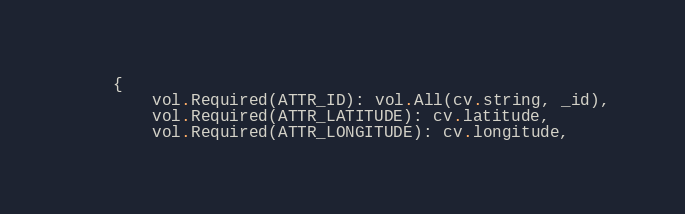<code> <loc_0><loc_0><loc_500><loc_500><_Python_>    {
        vol.Required(ATTR_ID): vol.All(cv.string, _id),
        vol.Required(ATTR_LATITUDE): cv.latitude,
        vol.Required(ATTR_LONGITUDE): cv.longitude,</code> 